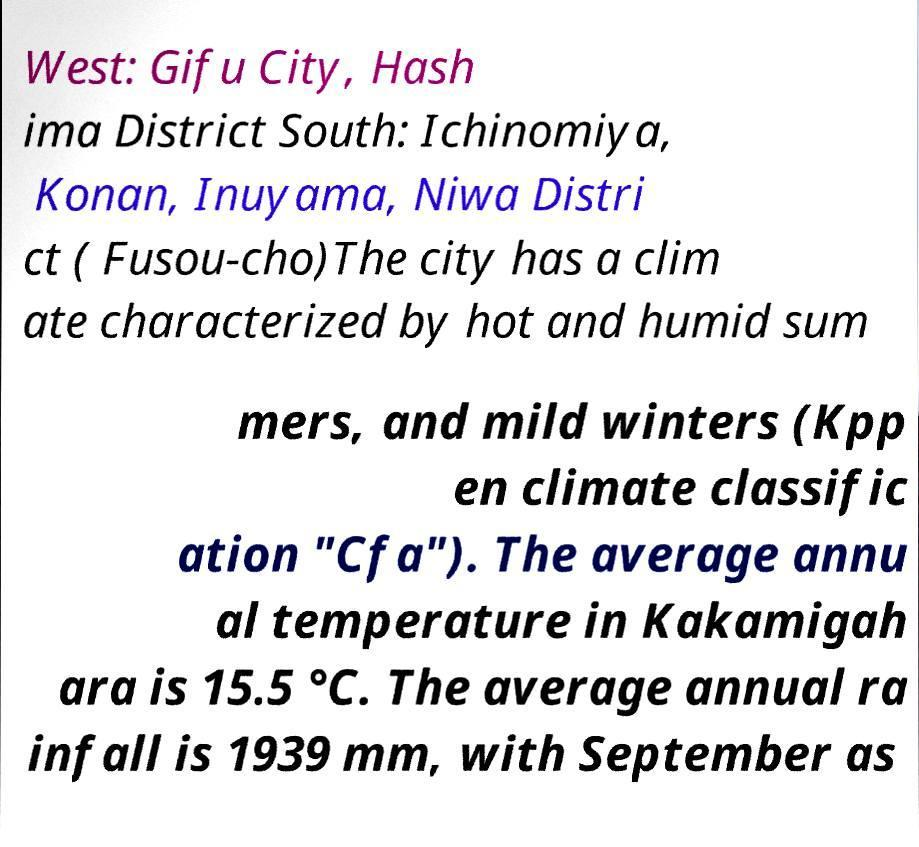I need the written content from this picture converted into text. Can you do that? West: Gifu City, Hash ima District South: Ichinomiya, Konan, Inuyama, Niwa Distri ct ( Fusou-cho)The city has a clim ate characterized by hot and humid sum mers, and mild winters (Kpp en climate classific ation "Cfa"). The average annu al temperature in Kakamigah ara is 15.5 °C. The average annual ra infall is 1939 mm, with September as 